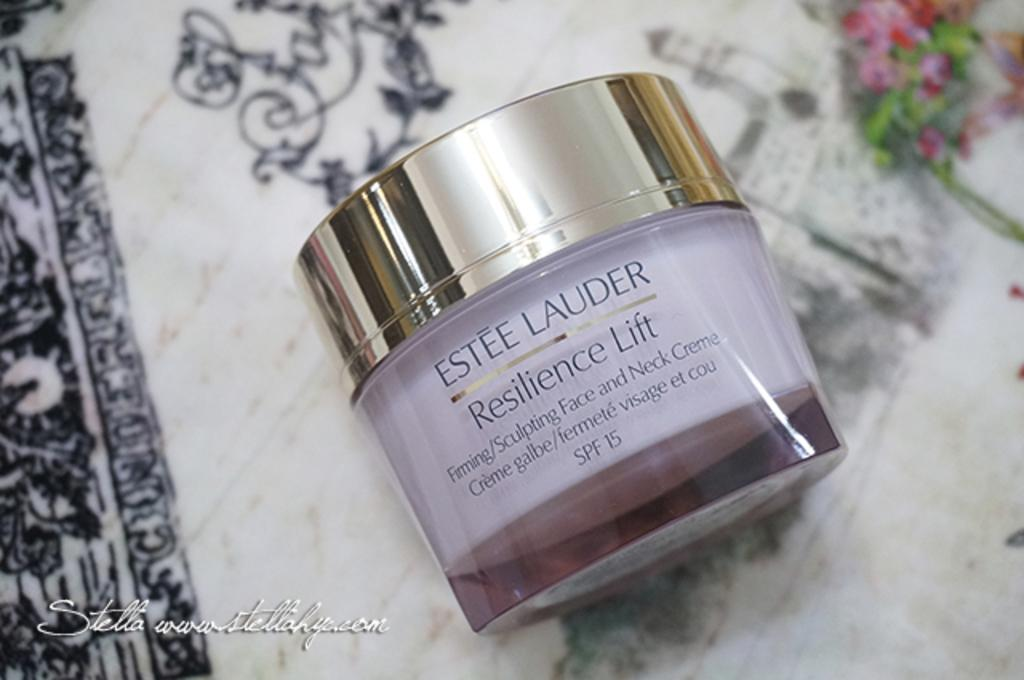Provide a one-sentence caption for the provided image. A bottle of Ester Lauder face cream called Resilience Lift. 